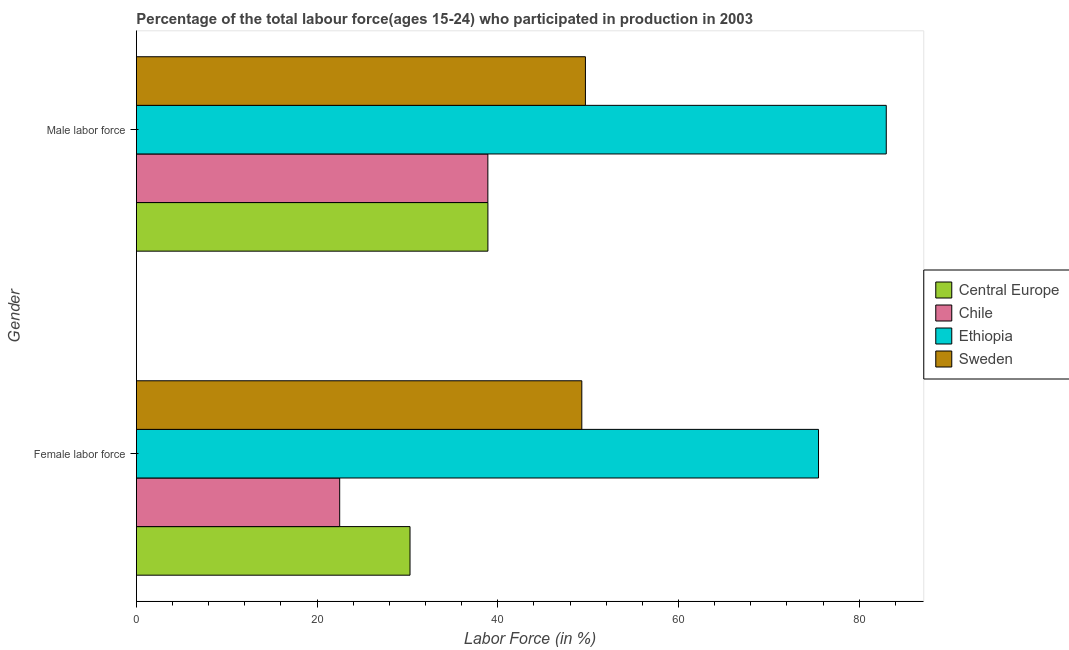How many different coloured bars are there?
Make the answer very short. 4. How many groups of bars are there?
Provide a succinct answer. 2. Are the number of bars per tick equal to the number of legend labels?
Give a very brief answer. Yes. Are the number of bars on each tick of the Y-axis equal?
Ensure brevity in your answer.  Yes. How many bars are there on the 2nd tick from the bottom?
Give a very brief answer. 4. What is the label of the 2nd group of bars from the top?
Offer a terse response. Female labor force. What is the percentage of male labour force in Chile?
Provide a short and direct response. 38.9. Across all countries, what is the maximum percentage of female labor force?
Provide a short and direct response. 75.5. Across all countries, what is the minimum percentage of female labor force?
Your response must be concise. 22.5. In which country was the percentage of male labour force maximum?
Offer a very short reply. Ethiopia. In which country was the percentage of male labour force minimum?
Offer a terse response. Chile. What is the total percentage of female labor force in the graph?
Ensure brevity in your answer.  177.58. What is the difference between the percentage of male labour force in Ethiopia and that in Chile?
Provide a succinct answer. 44.1. What is the difference between the percentage of female labor force in Chile and the percentage of male labour force in Ethiopia?
Give a very brief answer. -60.5. What is the average percentage of male labour force per country?
Your response must be concise. 52.63. What is the difference between the percentage of male labour force and percentage of female labor force in Chile?
Your answer should be compact. 16.4. What is the ratio of the percentage of female labor force in Ethiopia to that in Chile?
Provide a succinct answer. 3.36. What does the 2nd bar from the top in Female labor force represents?
Give a very brief answer. Ethiopia. Are all the bars in the graph horizontal?
Ensure brevity in your answer.  Yes. How many countries are there in the graph?
Offer a very short reply. 4. What is the difference between two consecutive major ticks on the X-axis?
Offer a very short reply. 20. Are the values on the major ticks of X-axis written in scientific E-notation?
Provide a succinct answer. No. Does the graph contain grids?
Provide a short and direct response. No. Where does the legend appear in the graph?
Your answer should be very brief. Center right. How are the legend labels stacked?
Make the answer very short. Vertical. What is the title of the graph?
Your answer should be very brief. Percentage of the total labour force(ages 15-24) who participated in production in 2003. What is the label or title of the Y-axis?
Provide a short and direct response. Gender. What is the Labor Force (in %) of Central Europe in Female labor force?
Offer a very short reply. 30.28. What is the Labor Force (in %) in Chile in Female labor force?
Ensure brevity in your answer.  22.5. What is the Labor Force (in %) of Ethiopia in Female labor force?
Your answer should be compact. 75.5. What is the Labor Force (in %) in Sweden in Female labor force?
Your answer should be very brief. 49.3. What is the Labor Force (in %) of Central Europe in Male labor force?
Provide a short and direct response. 38.91. What is the Labor Force (in %) of Chile in Male labor force?
Keep it short and to the point. 38.9. What is the Labor Force (in %) in Sweden in Male labor force?
Provide a short and direct response. 49.7. Across all Gender, what is the maximum Labor Force (in %) of Central Europe?
Provide a succinct answer. 38.91. Across all Gender, what is the maximum Labor Force (in %) of Chile?
Keep it short and to the point. 38.9. Across all Gender, what is the maximum Labor Force (in %) in Ethiopia?
Keep it short and to the point. 83. Across all Gender, what is the maximum Labor Force (in %) in Sweden?
Provide a succinct answer. 49.7. Across all Gender, what is the minimum Labor Force (in %) of Central Europe?
Give a very brief answer. 30.28. Across all Gender, what is the minimum Labor Force (in %) of Ethiopia?
Provide a short and direct response. 75.5. Across all Gender, what is the minimum Labor Force (in %) of Sweden?
Offer a very short reply. 49.3. What is the total Labor Force (in %) in Central Europe in the graph?
Ensure brevity in your answer.  69.19. What is the total Labor Force (in %) of Chile in the graph?
Keep it short and to the point. 61.4. What is the total Labor Force (in %) of Ethiopia in the graph?
Offer a very short reply. 158.5. What is the difference between the Labor Force (in %) in Central Europe in Female labor force and that in Male labor force?
Keep it short and to the point. -8.62. What is the difference between the Labor Force (in %) of Chile in Female labor force and that in Male labor force?
Your answer should be compact. -16.4. What is the difference between the Labor Force (in %) in Sweden in Female labor force and that in Male labor force?
Provide a succinct answer. -0.4. What is the difference between the Labor Force (in %) in Central Europe in Female labor force and the Labor Force (in %) in Chile in Male labor force?
Offer a very short reply. -8.62. What is the difference between the Labor Force (in %) in Central Europe in Female labor force and the Labor Force (in %) in Ethiopia in Male labor force?
Offer a terse response. -52.72. What is the difference between the Labor Force (in %) of Central Europe in Female labor force and the Labor Force (in %) of Sweden in Male labor force?
Your response must be concise. -19.42. What is the difference between the Labor Force (in %) of Chile in Female labor force and the Labor Force (in %) of Ethiopia in Male labor force?
Your answer should be very brief. -60.5. What is the difference between the Labor Force (in %) of Chile in Female labor force and the Labor Force (in %) of Sweden in Male labor force?
Your answer should be very brief. -27.2. What is the difference between the Labor Force (in %) in Ethiopia in Female labor force and the Labor Force (in %) in Sweden in Male labor force?
Offer a terse response. 25.8. What is the average Labor Force (in %) in Central Europe per Gender?
Provide a succinct answer. 34.6. What is the average Labor Force (in %) of Chile per Gender?
Your response must be concise. 30.7. What is the average Labor Force (in %) in Ethiopia per Gender?
Offer a terse response. 79.25. What is the average Labor Force (in %) of Sweden per Gender?
Offer a terse response. 49.5. What is the difference between the Labor Force (in %) in Central Europe and Labor Force (in %) in Chile in Female labor force?
Ensure brevity in your answer.  7.78. What is the difference between the Labor Force (in %) of Central Europe and Labor Force (in %) of Ethiopia in Female labor force?
Offer a very short reply. -45.22. What is the difference between the Labor Force (in %) of Central Europe and Labor Force (in %) of Sweden in Female labor force?
Offer a terse response. -19.02. What is the difference between the Labor Force (in %) in Chile and Labor Force (in %) in Ethiopia in Female labor force?
Give a very brief answer. -53. What is the difference between the Labor Force (in %) in Chile and Labor Force (in %) in Sweden in Female labor force?
Keep it short and to the point. -26.8. What is the difference between the Labor Force (in %) of Ethiopia and Labor Force (in %) of Sweden in Female labor force?
Offer a very short reply. 26.2. What is the difference between the Labor Force (in %) of Central Europe and Labor Force (in %) of Chile in Male labor force?
Ensure brevity in your answer.  0.01. What is the difference between the Labor Force (in %) of Central Europe and Labor Force (in %) of Ethiopia in Male labor force?
Keep it short and to the point. -44.09. What is the difference between the Labor Force (in %) in Central Europe and Labor Force (in %) in Sweden in Male labor force?
Offer a very short reply. -10.79. What is the difference between the Labor Force (in %) of Chile and Labor Force (in %) of Ethiopia in Male labor force?
Your response must be concise. -44.1. What is the difference between the Labor Force (in %) of Ethiopia and Labor Force (in %) of Sweden in Male labor force?
Keep it short and to the point. 33.3. What is the ratio of the Labor Force (in %) of Central Europe in Female labor force to that in Male labor force?
Ensure brevity in your answer.  0.78. What is the ratio of the Labor Force (in %) of Chile in Female labor force to that in Male labor force?
Give a very brief answer. 0.58. What is the ratio of the Labor Force (in %) in Ethiopia in Female labor force to that in Male labor force?
Your answer should be compact. 0.91. What is the ratio of the Labor Force (in %) in Sweden in Female labor force to that in Male labor force?
Keep it short and to the point. 0.99. What is the difference between the highest and the second highest Labor Force (in %) of Central Europe?
Offer a terse response. 8.62. What is the difference between the highest and the second highest Labor Force (in %) of Chile?
Provide a succinct answer. 16.4. What is the difference between the highest and the second highest Labor Force (in %) of Ethiopia?
Ensure brevity in your answer.  7.5. What is the difference between the highest and the second highest Labor Force (in %) in Sweden?
Ensure brevity in your answer.  0.4. What is the difference between the highest and the lowest Labor Force (in %) in Central Europe?
Your answer should be very brief. 8.62. 